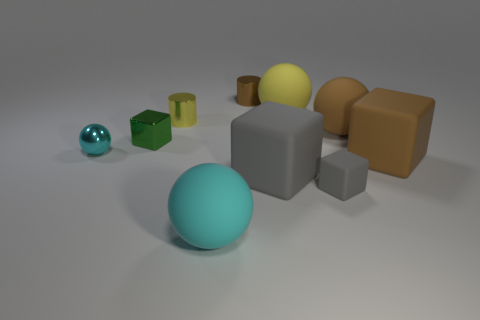Is there any other thing that is the same shape as the large gray object?
Keep it short and to the point. Yes. There is another tiny object that is the same shape as the cyan matte object; what color is it?
Ensure brevity in your answer.  Cyan. What size is the green metal object?
Offer a very short reply. Small. Are there fewer yellow cylinders in front of the brown rubber ball than cyan rubber objects?
Give a very brief answer. Yes. Are the large gray object and the cylinder that is in front of the tiny brown metallic thing made of the same material?
Your answer should be compact. No. There is a small block that is to the left of the small shiny cylinder to the left of the brown shiny cylinder; are there any green blocks that are left of it?
Provide a succinct answer. No. Are there any other things that have the same size as the brown rubber block?
Give a very brief answer. Yes. The ball that is the same material as the green block is what color?
Provide a succinct answer. Cyan. There is a sphere that is both right of the tiny metallic cube and on the left side of the large gray matte cube; how big is it?
Your answer should be very brief. Large. Is the number of small gray things that are on the right side of the brown metallic cylinder less than the number of big brown matte objects behind the tiny gray thing?
Ensure brevity in your answer.  Yes. 